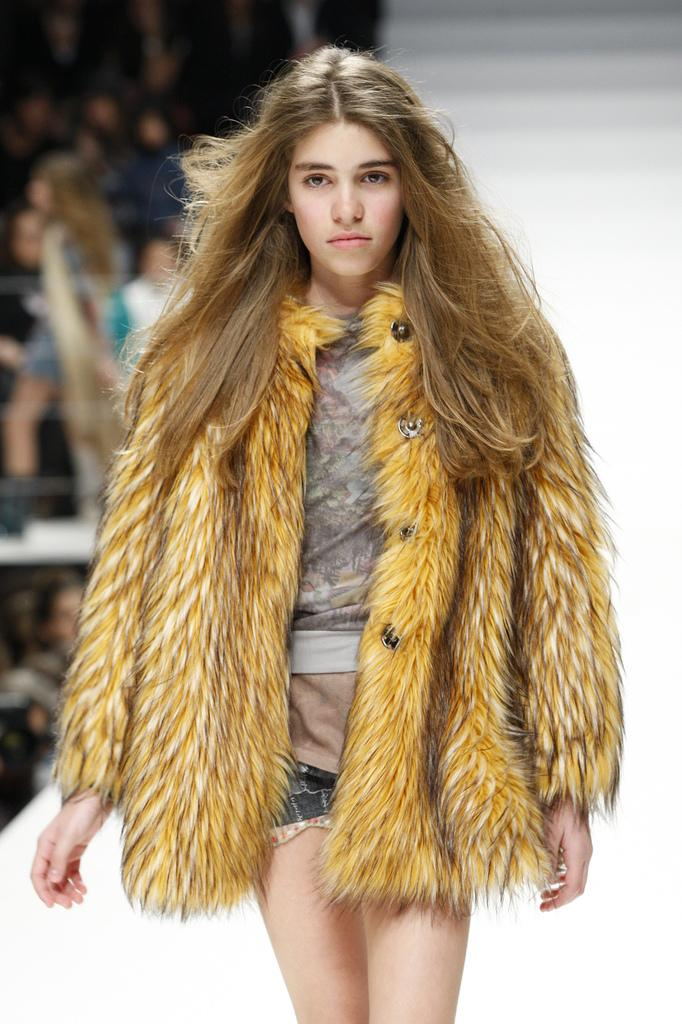Who is the main subject in the image? There is a lady in the image. What is the lady wearing? The lady is wearing a fur jacket. Can you describe the background of the image? The background of the image is blurry, but there are people visible. Can you tell me how many deer are visible in the image? There are no deer present in the image. Is the lady swimming in the image? There is no indication that the lady is swimming in the image. 